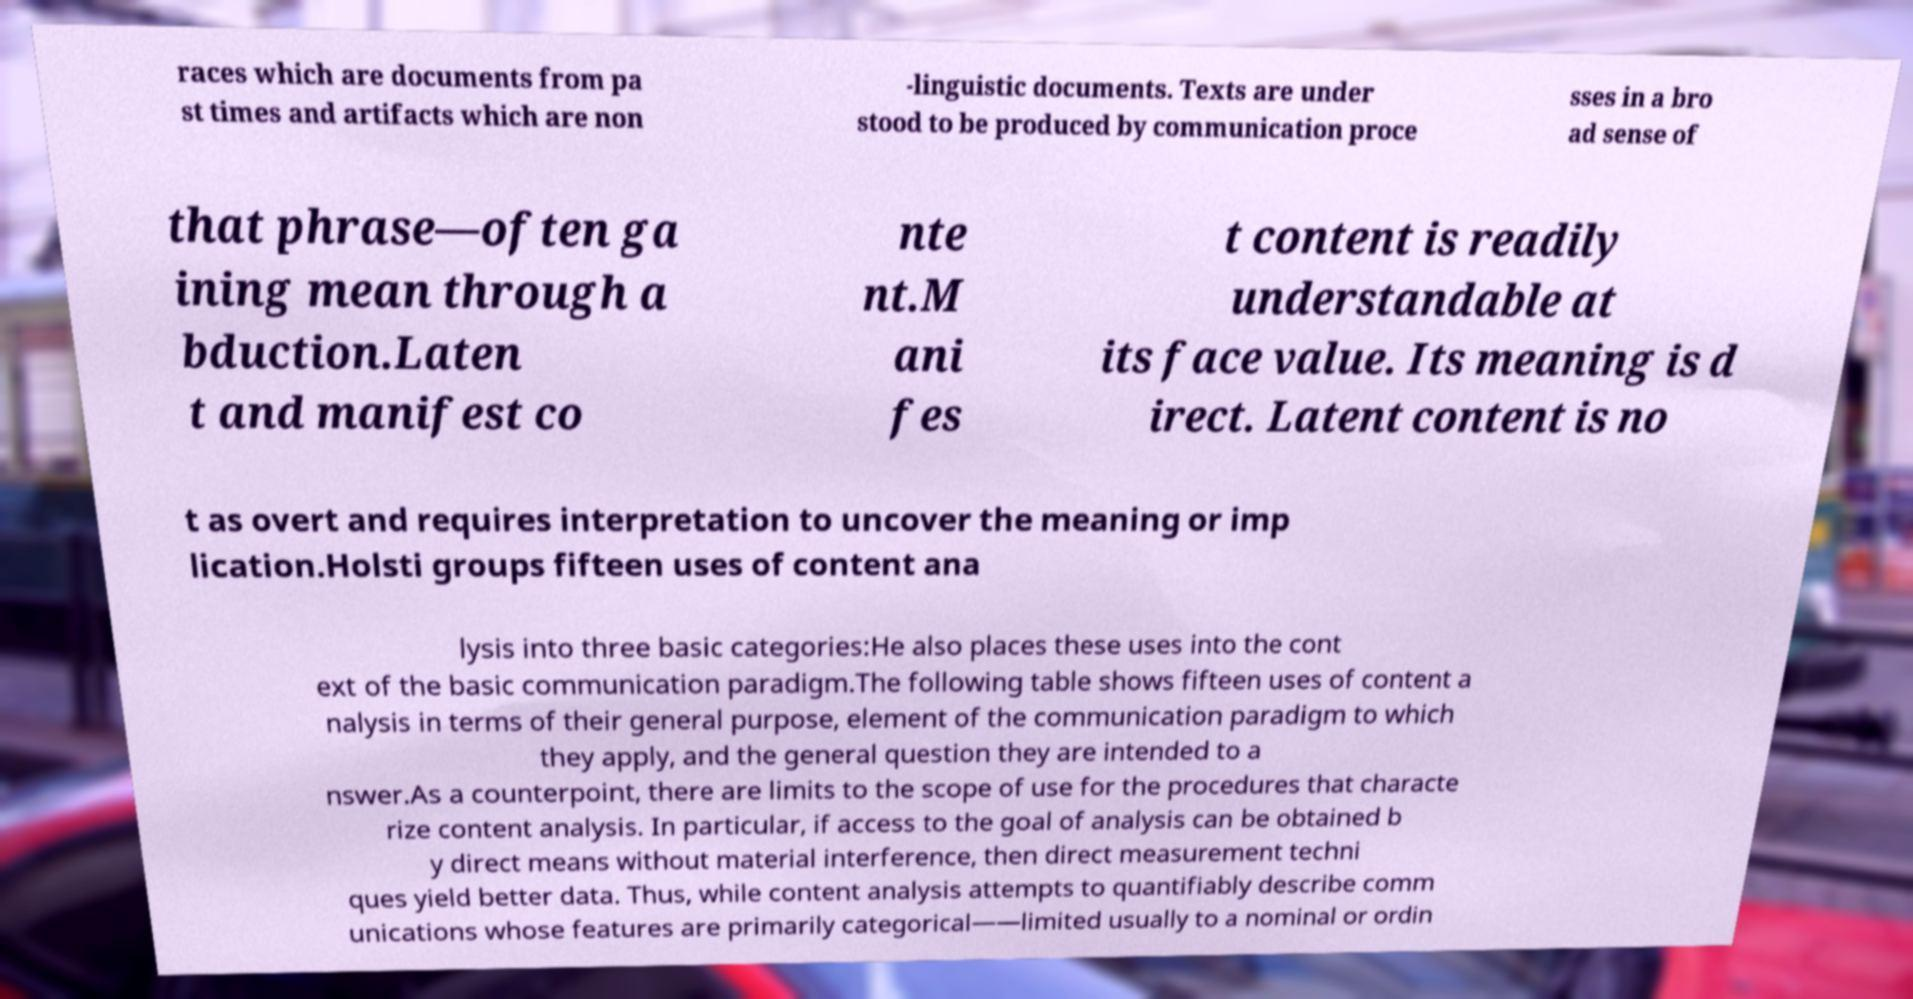Can you read and provide the text displayed in the image?This photo seems to have some interesting text. Can you extract and type it out for me? races which are documents from pa st times and artifacts which are non -linguistic documents. Texts are under stood to be produced by communication proce sses in a bro ad sense of that phrase—often ga ining mean through a bduction.Laten t and manifest co nte nt.M ani fes t content is readily understandable at its face value. Its meaning is d irect. Latent content is no t as overt and requires interpretation to uncover the meaning or imp lication.Holsti groups fifteen uses of content ana lysis into three basic categories:He also places these uses into the cont ext of the basic communication paradigm.The following table shows fifteen uses of content a nalysis in terms of their general purpose, element of the communication paradigm to which they apply, and the general question they are intended to a nswer.As a counterpoint, there are limits to the scope of use for the procedures that characte rize content analysis. In particular, if access to the goal of analysis can be obtained b y direct means without material interference, then direct measurement techni ques yield better data. Thus, while content analysis attempts to quantifiably describe comm unications whose features are primarily categorical——limited usually to a nominal or ordin 